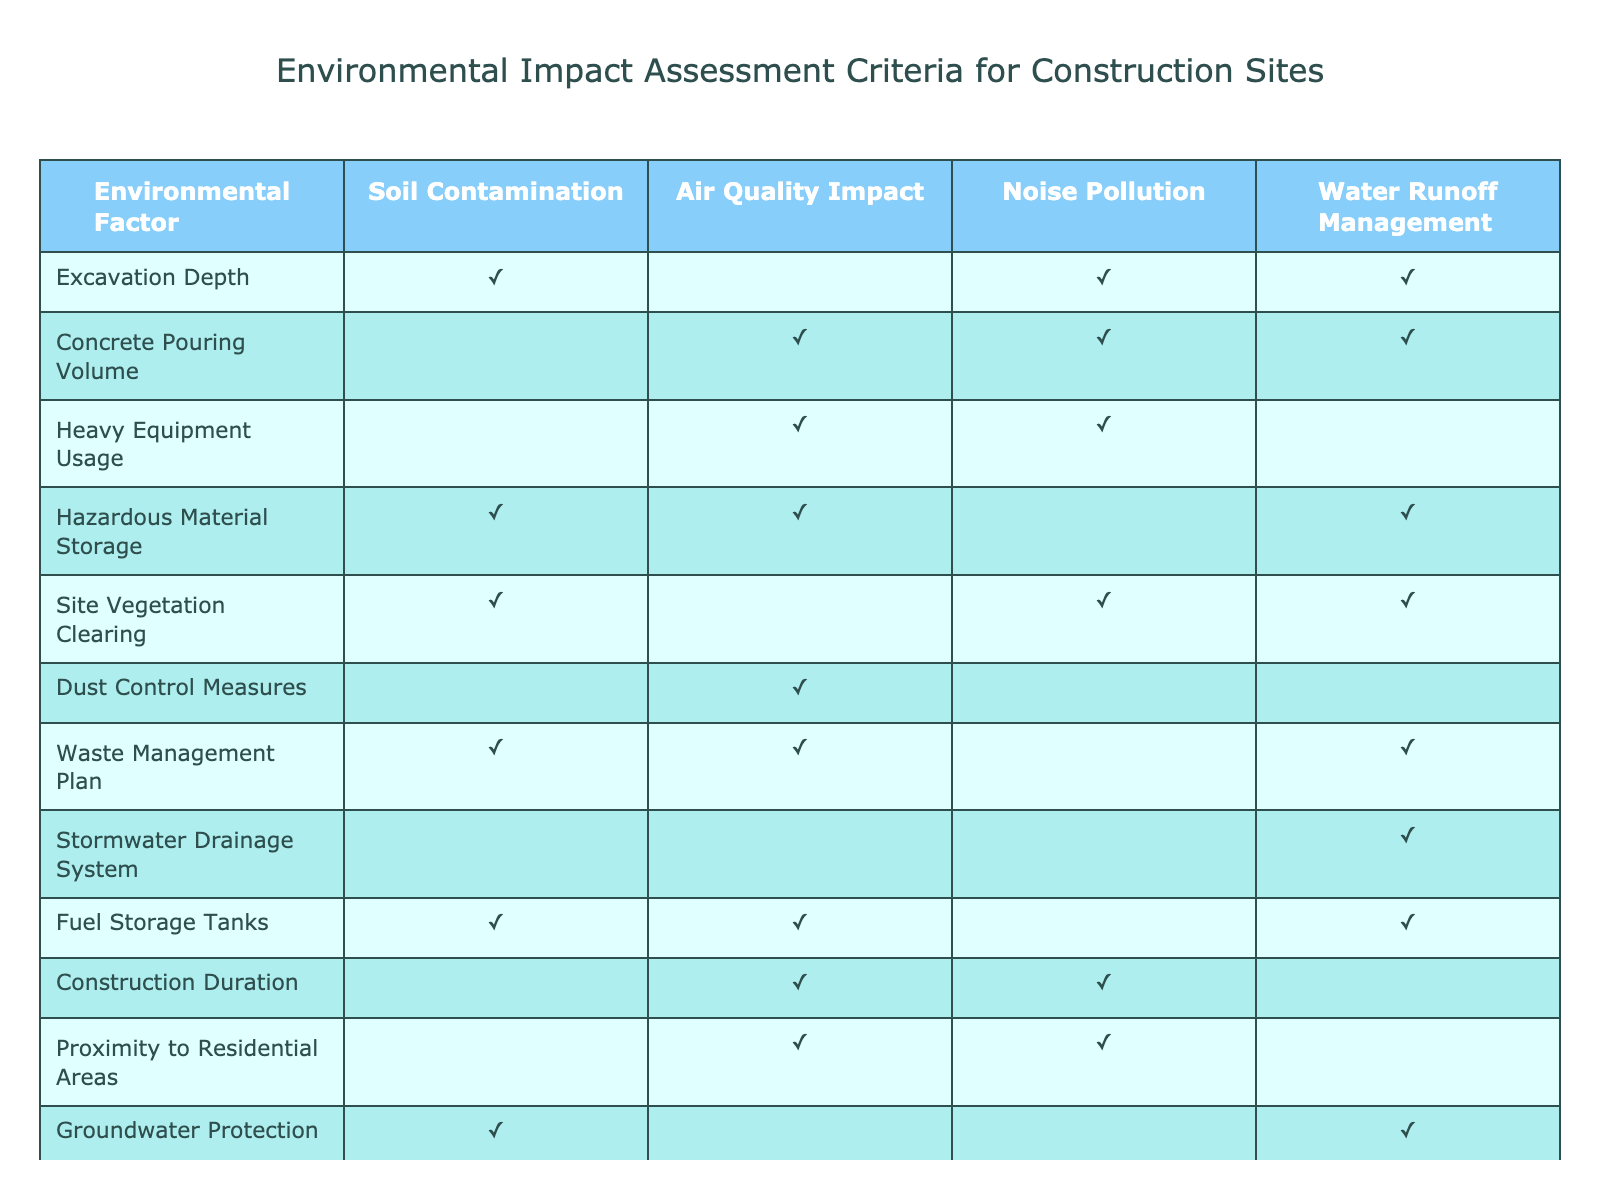What environmental factor is related to soil contamination during excavation? According to the table, "Excavation Depth" has a checkmark (TRUE) under the "Soil Contamination" column, indicating that it relates to this environmental factor.
Answer: Excavation Depth How many environmental factors impact air quality? In the table, there are several factors that have checkmarks (TRUE) under the "Air Quality Impact" column: "Concrete Pouring Volume," "Heavy Equipment Usage," "Construction Duration," and "Proximity to Residential Areas." Counting these gives us a total of 5 factors that impact air quality.
Answer: 5 Is waste management planning significant for water runoff management? The table shows that "Waste Management Plan" has a checkmark (TRUE) under the "Water Runoff Management" column, indicating a positive relationship.
Answer: Yes Which environmental factor has the least impact on noise pollution? By examining the table, we see that "Stormwater Drainage System" has no checkmark (FALSE) under the "Noise Pollution" column, indicating it is the only factor with no impact on noise pollution.
Answer: Stormwater Drainage System What is the total number of environmental factors that involve the storage of hazardous materials? The table lists "Hazardous Material Storage" and "Fuel Storage Tanks" as factors with (TRUE) in the respective rows. Adding them up gives a total of 2 factors related to the storage of hazardous materials.
Answer: 2 Does site vegetation clearing contribute to air quality impact? In the table, "Site Vegetation Clearing" has a checkmark (FALSE) under the "Air Quality Impact" column, indicating that it does not contribute to air quality issues.
Answer: No Which two environmental factors are both concerned with noise pollution and air quality? Referring to the table, we observe "Heavy Equipment Usage" and "Traffic Management Plan," both of which have checkmarks (TRUE) in the columns for "Noise Pollution" and "Air Quality Impact." Thus, these are the two factors of interest.
Answer: Heavy Equipment Usage, Traffic Management Plan How does the excavation depth relate to other factors impacting soil contamination? "Excavation Depth" is related to "Hazardous Material Storage," "Site Vegetation Clearing," and "Waste Management Plan," all marked (TRUE) for "Soil Contamination." Hence, it connects with these factors regarding soil contamination.
Answer: Hazardous Material Storage, Site Vegetation Clearing, Waste Management Plan What is the relationship between asbestos removal and hazardous materials? The table indicates both "Asbestos Removal" and "Hazardous Material Storage" have checkmarks (TRUE) under the respective columns, suggesting both are critical concerning hazardous materials.
Answer: Both are critical 